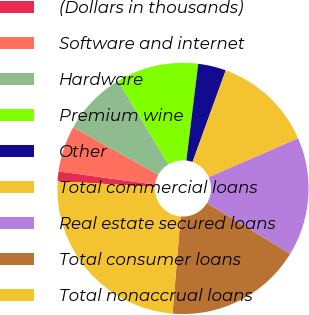<chart> <loc_0><loc_0><loc_500><loc_500><pie_chart><fcel>(Dollars in thousands)<fcel>Software and internet<fcel>Hardware<fcel>Premium wine<fcel>Other<fcel>Total commercial loans<fcel>Real estate secured loans<fcel>Total consumer loans<fcel>Total nonaccrual loans<nl><fcel>1.25%<fcel>5.92%<fcel>8.26%<fcel>10.59%<fcel>3.59%<fcel>12.93%<fcel>15.26%<fcel>17.6%<fcel>24.6%<nl></chart> 